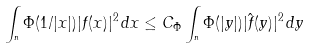<formula> <loc_0><loc_0><loc_500><loc_500>\int _ { \real ^ { n } } \Phi ( 1 / | x | ) | f ( x ) | ^ { 2 } \, d x \leq C _ { \Phi } \int _ { \real ^ { n } } \Phi ( | y | ) | \hat { f } ( y ) | ^ { 2 } \, d y</formula> 